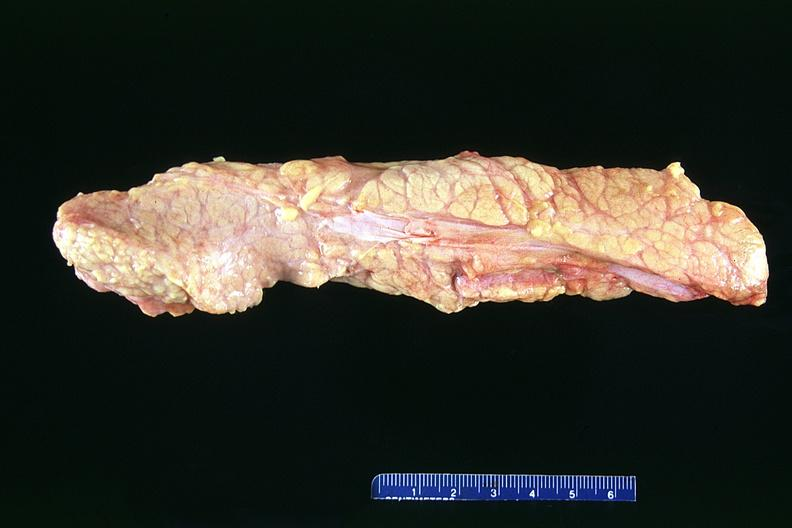does this image show normal pancreas?
Answer the question using a single word or phrase. Yes 